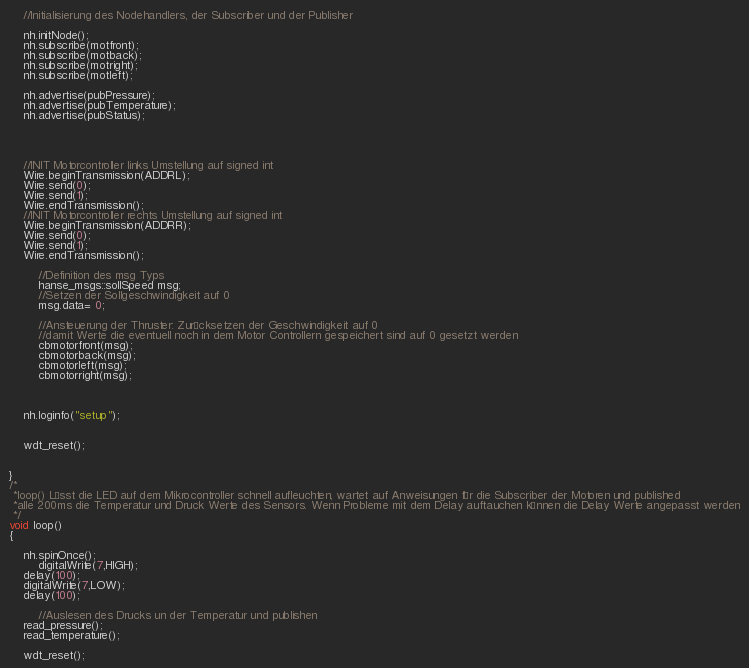Convert code to text. <code><loc_0><loc_0><loc_500><loc_500><_C++_>
	//Initialisierung des Nodehandlers, der Subscriber und der Publisher

	nh.initNode();
	nh.subscribe(motfront);
	nh.subscribe(motback);
	nh.subscribe(motright);
	nh.subscribe(motleft);
  
   	nh.advertise(pubPressure);
   	nh.advertise(pubTemperature);
	nh.advertise(pubStatus);	




  	//INIT Motorcontroller links Umstellung auf signed int
  	Wire.beginTransmission(ADDRL);
  	Wire.send(0);
  	Wire.send(1);
  	Wire.endTransmission();
  	//INIT Motorcontroller rechts Umstellung auf signed int
  	Wire.beginTransmission(ADDRR);
  	Wire.send(0);
  	Wire.send(1);
  	Wire.endTransmission();

        //Definition des msg Typs
        hanse_msgs::sollSpeed msg;
        //Setzen der Sollgeschwindigkeit auf 0
        msg.data= 0;

        //Ansteuerung der Thruster: Zurücksetzen der Geschwindigkeit auf 0
        //damit Werte die eventuell noch in dem Motor Controllern gespeichert sind auf 0 gesetzt werden
        cbmotorfront(msg);
        cbmotorback(msg);
        cbmotorleft(msg);
        cbmotorright(msg);



	nh.loginfo("setup");


	wdt_reset();


}
/*
 *loop() Lässt die LED auf dem Mikrocontroller schnell aufleuchten, wartet auf Anweisungen für die Subscriber der Motoren und published 
 *alle 200ms die Temperatur und Druck Werte des Sensors. Wenn Probleme mit dem Delay auftauchen können die Delay Werte angepasst werden
 */
void loop()
{
	 
	nh.spinOnce();
        digitalWrite(7,HIGH);
	delay(100);
	digitalWrite(7,LOW);
	delay(100);

        //Auslesen des Drucks un der Temperatur und publishen
	read_pressure();
  	read_temperature();

	wdt_reset();
</code> 